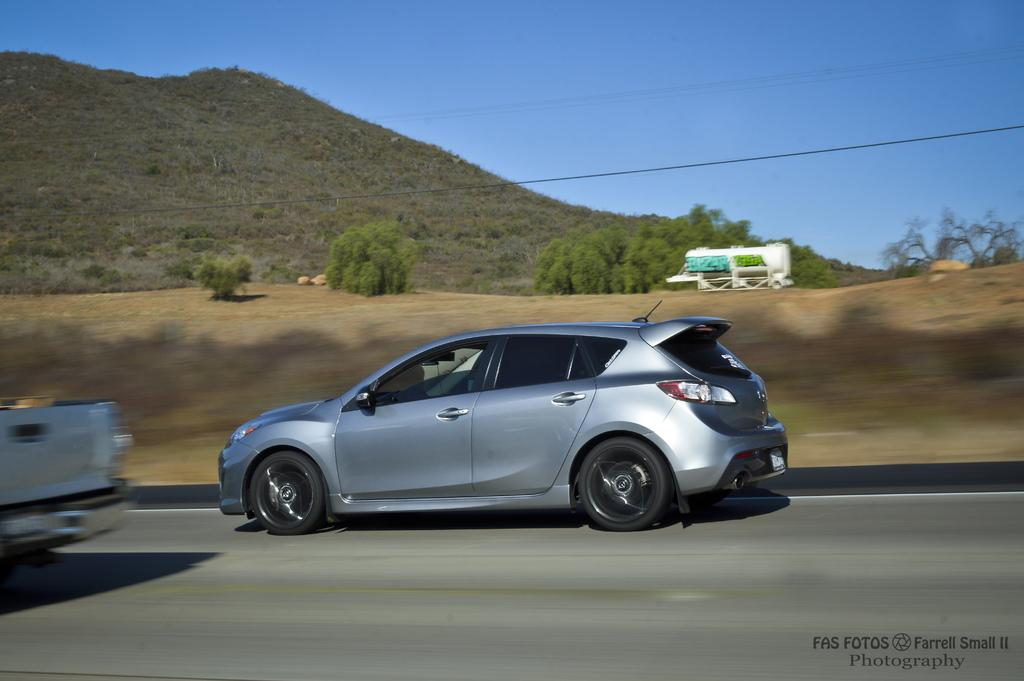What is the main subject of the image? There is a car in the image. What can be seen behind the car? There are trees behind the car. What is visible behind the trees? There is a mountain behind the trees. What can be inferred about the car's movement in the image? The image was captured while the vehicle was in motion. What type of apparel is the car wearing in the image? Cars do not wear apparel; the question is not applicable to the image. What appliance can be seen on the mountain in the image? There are no appliances visible on the mountain in the image. 